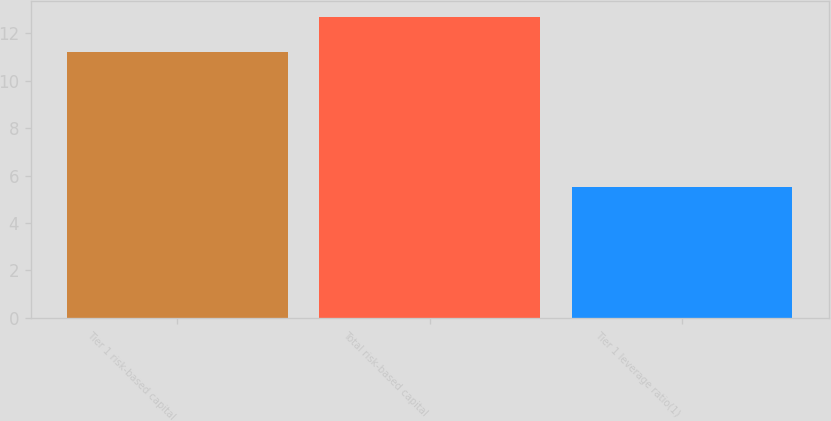<chart> <loc_0><loc_0><loc_500><loc_500><bar_chart><fcel>Tier 1 risk-based capital<fcel>Total risk-based capital<fcel>Tier 1 leverage ratio(1)<nl><fcel>11.2<fcel>12.7<fcel>5.5<nl></chart> 